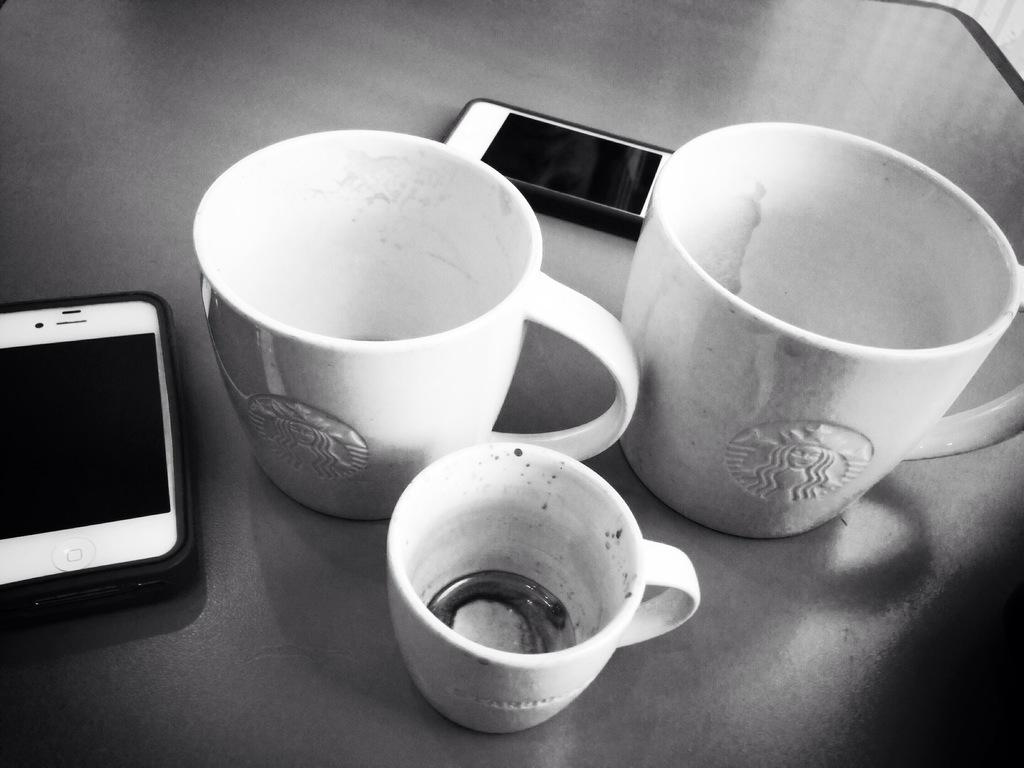How many cups are visible in the image? There are three cups in the image. What other objects can be seen in the image besides the cups? There are two mobile phones in the image. What type of juice is being served in the cups in the image? There is no juice present in the image; it only shows three cups and two mobile phones. 